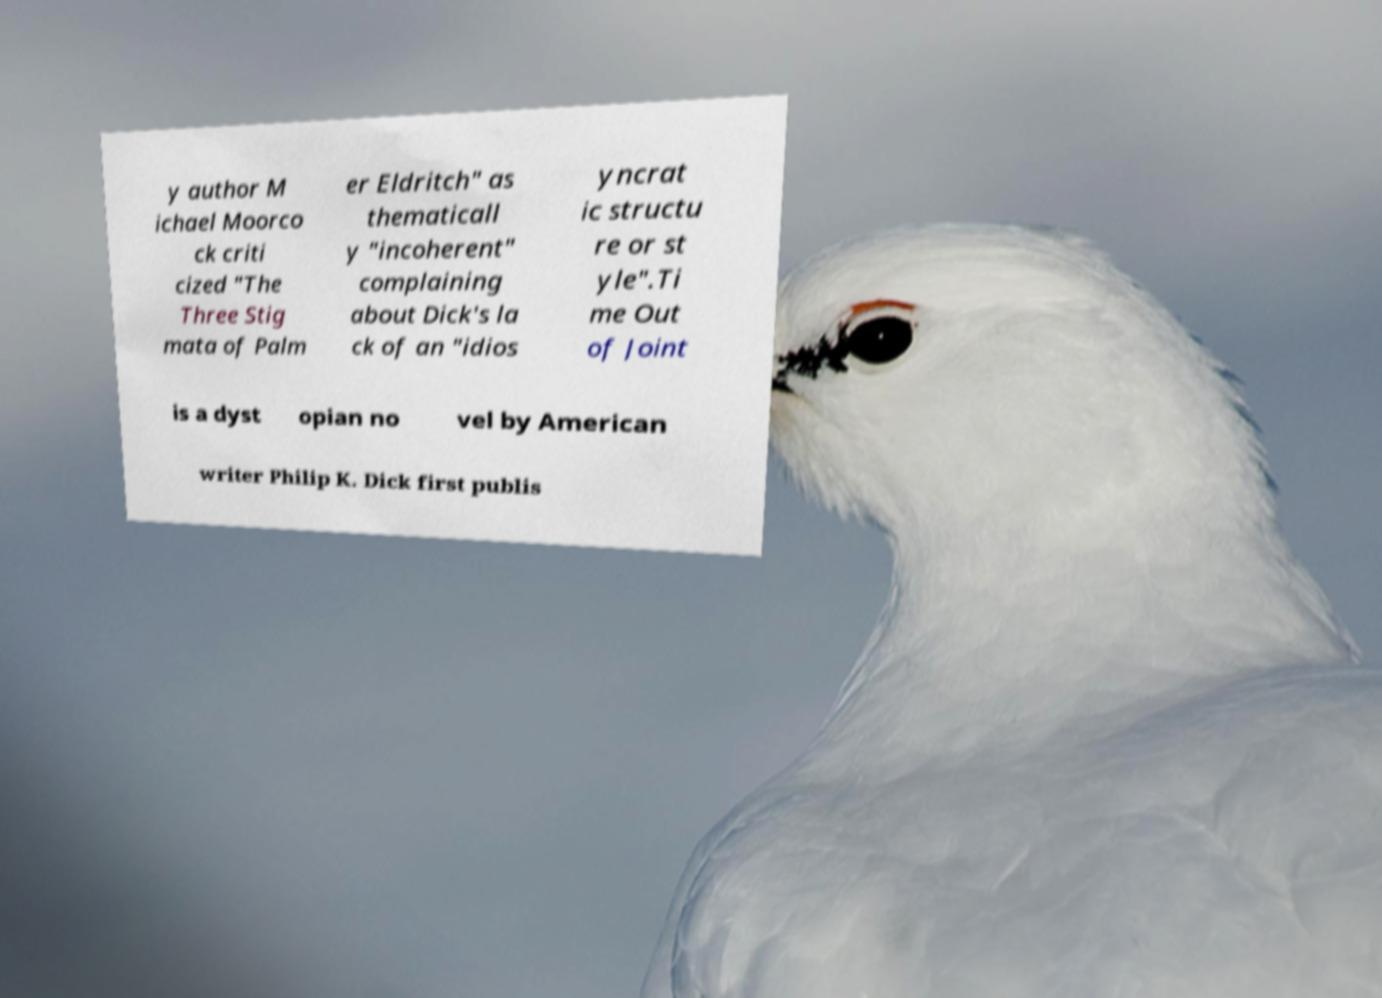Could you assist in decoding the text presented in this image and type it out clearly? y author M ichael Moorco ck criti cized "The Three Stig mata of Palm er Eldritch" as thematicall y "incoherent" complaining about Dick's la ck of an "idios yncrat ic structu re or st yle".Ti me Out of Joint is a dyst opian no vel by American writer Philip K. Dick first publis 